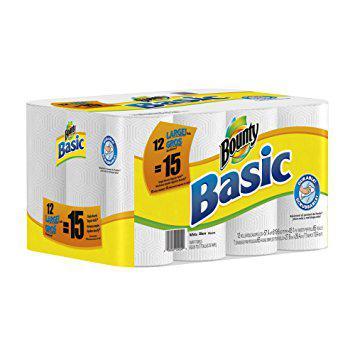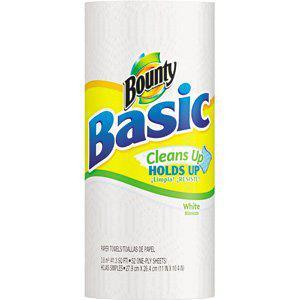The first image is the image on the left, the second image is the image on the right. For the images shown, is this caption "The left image contains a multipack of paper towel rolls with a baby's face on the front, and the right image contains packaging with the same color scheme as the left." true? Answer yes or no. No. The first image is the image on the left, the second image is the image on the right. Examine the images to the left and right. Is the description "There is a child with a messy face." accurate? Answer yes or no. No. 